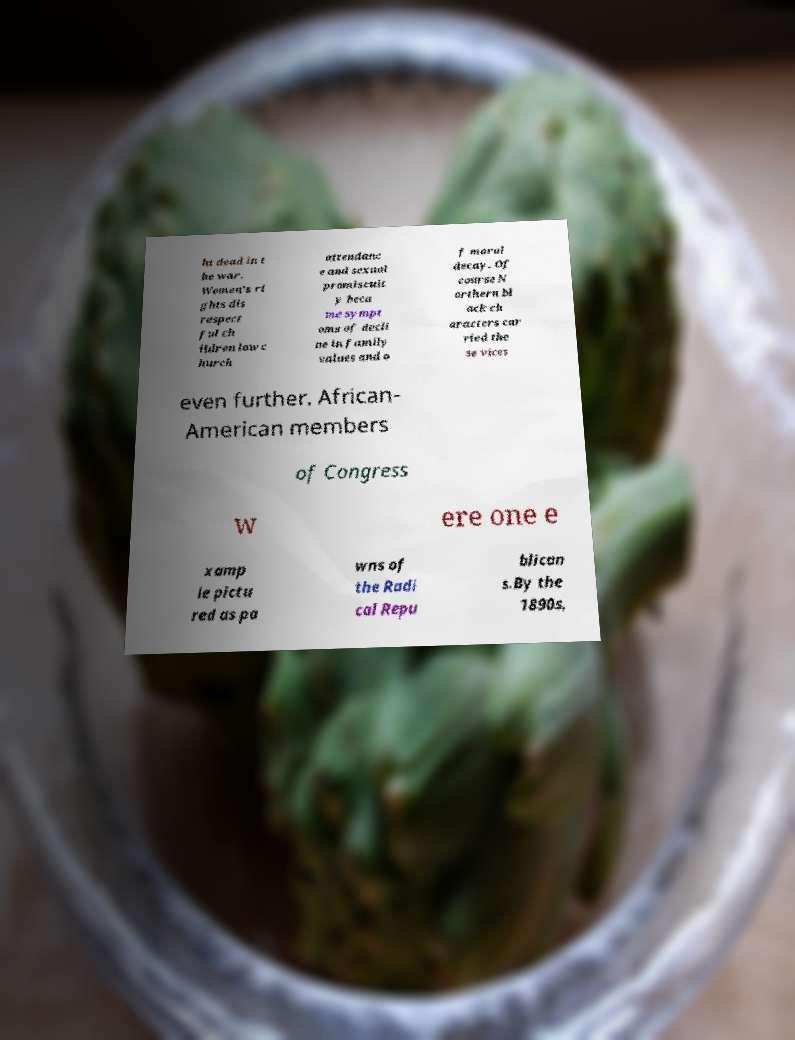I need the written content from this picture converted into text. Can you do that? ht dead in t he war. Women's ri ghts dis respect ful ch ildren low c hurch attendanc e and sexual promiscuit y beca me sympt oms of decli ne in family values and o f moral decay. Of course N orthern bl ack ch aracters car ried the se vices even further. African- American members of Congress w ere one e xamp le pictu red as pa wns of the Radi cal Repu blican s.By the 1890s, 